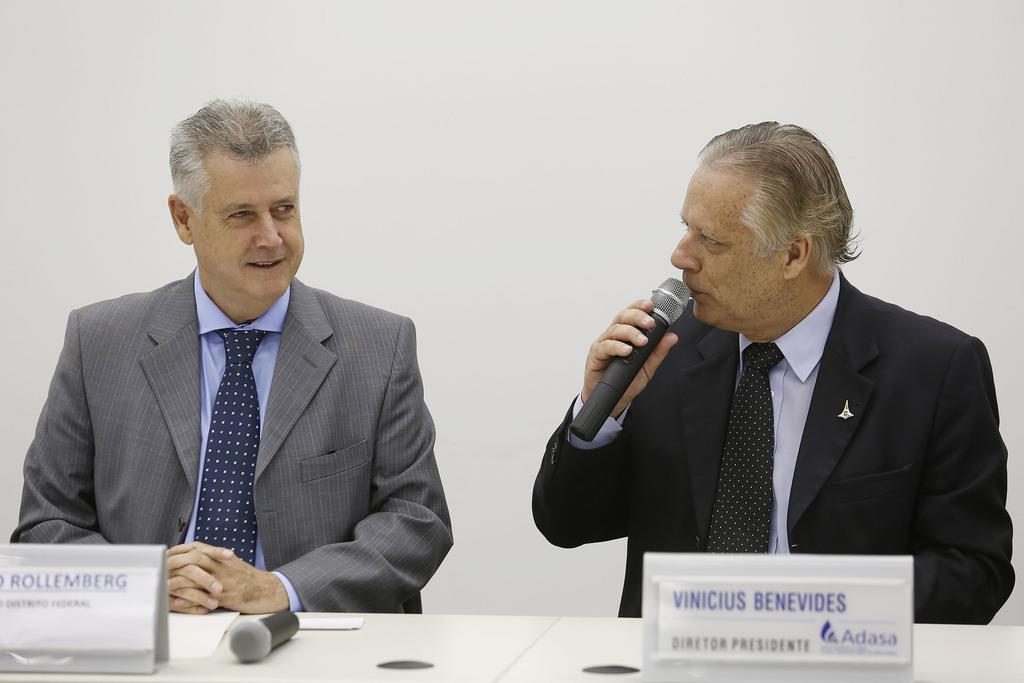How would you summarize this image in a sentence or two? There are two man sitting in the chair in front of a table on which a name plates and a mic are present. One man is holding a mic in his hand and talking. In the background there is a wall here. 